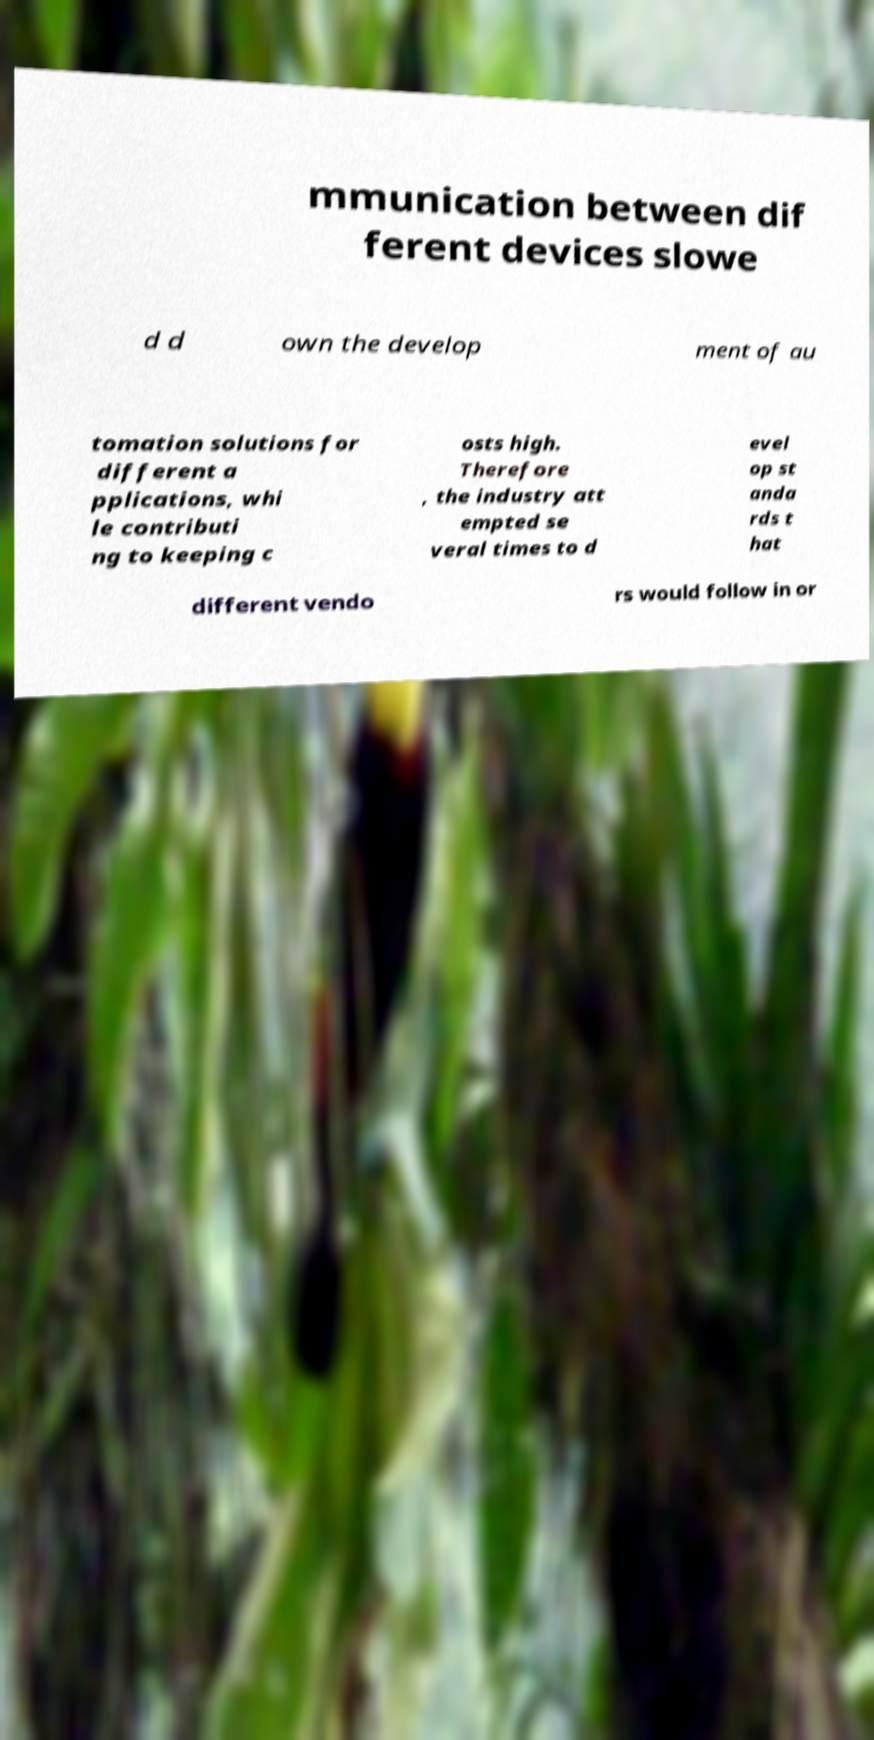Please identify and transcribe the text found in this image. mmunication between dif ferent devices slowe d d own the develop ment of au tomation solutions for different a pplications, whi le contributi ng to keeping c osts high. Therefore , the industry att empted se veral times to d evel op st anda rds t hat different vendo rs would follow in or 